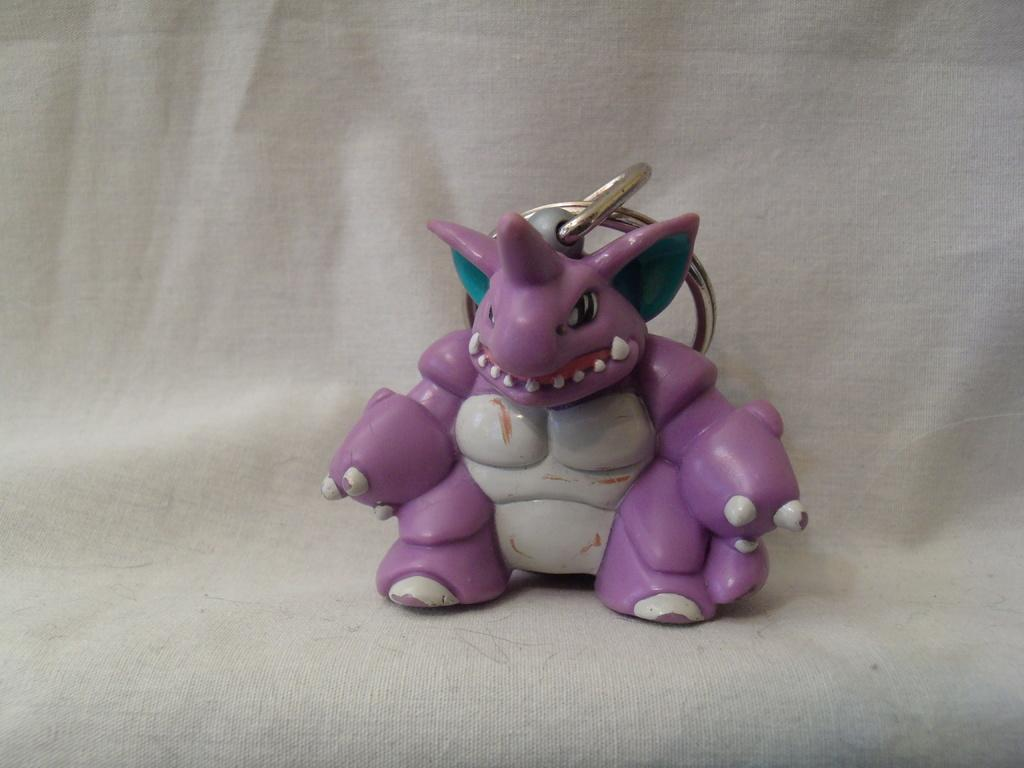What is the color of the toy in the image? The toy in the image has a pink and white color. What material is used for the rings on the toy? The rings on the toy are made of steel. On what surface is the toy placed? The toy is on a white surface. What role does the actor play in the image? There is no actor present in the image; it features a toy with steel rings on a white surface. 